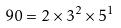<formula> <loc_0><loc_0><loc_500><loc_500>9 0 = 2 \times 3 ^ { 2 } \times 5 ^ { 1 }</formula> 